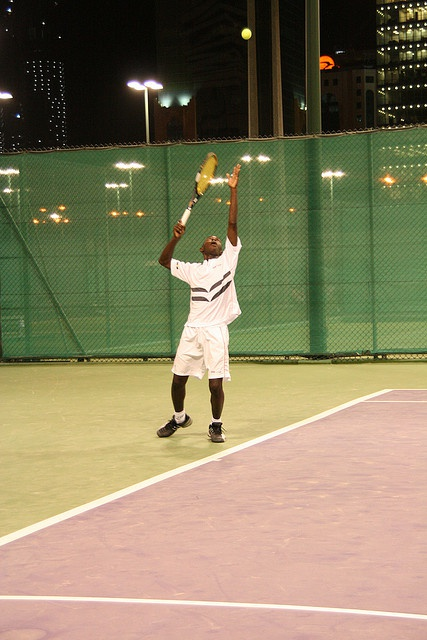Describe the objects in this image and their specific colors. I can see people in black, ivory, darkgreen, and tan tones, tennis racket in black, orange, darkgreen, olive, and tan tones, people in black tones, and sports ball in black, khaki, olive, and gold tones in this image. 